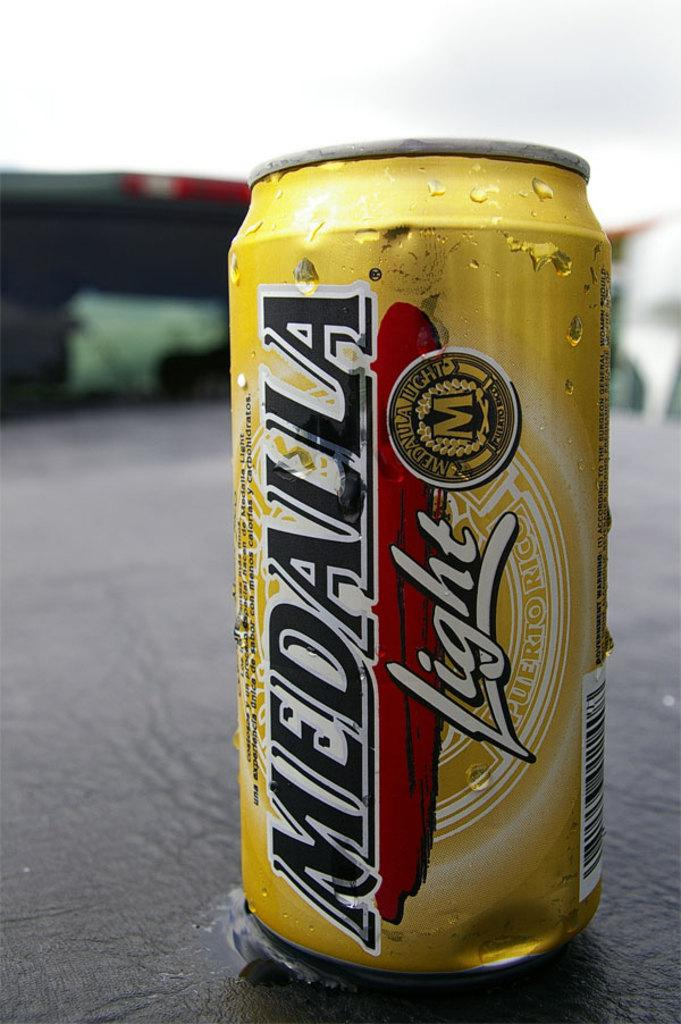Provide a one-sentence caption for the provided image. A Medalla light can has condensation on the side. 